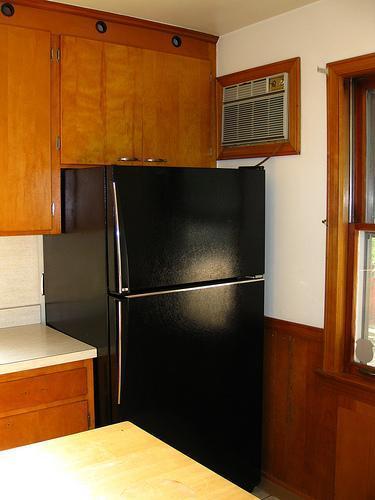How many doors are on the fridge?
Give a very brief answer. 2. 